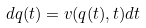Convert formula to latex. <formula><loc_0><loc_0><loc_500><loc_500>d { q } ( t ) = { v } ( q ( t ) , t ) d t</formula> 